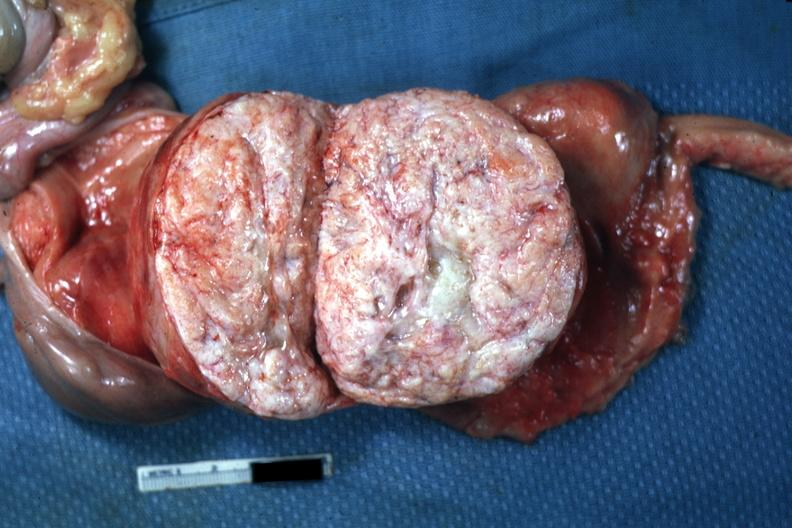what is quite typical close-up photo?
Answer the question using a single word or phrase. Myoma lesion 